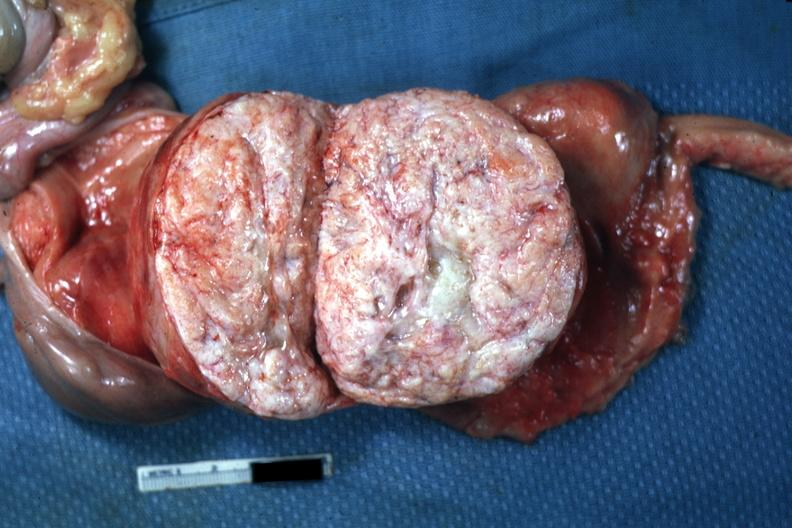what is quite typical close-up photo?
Answer the question using a single word or phrase. Myoma lesion 